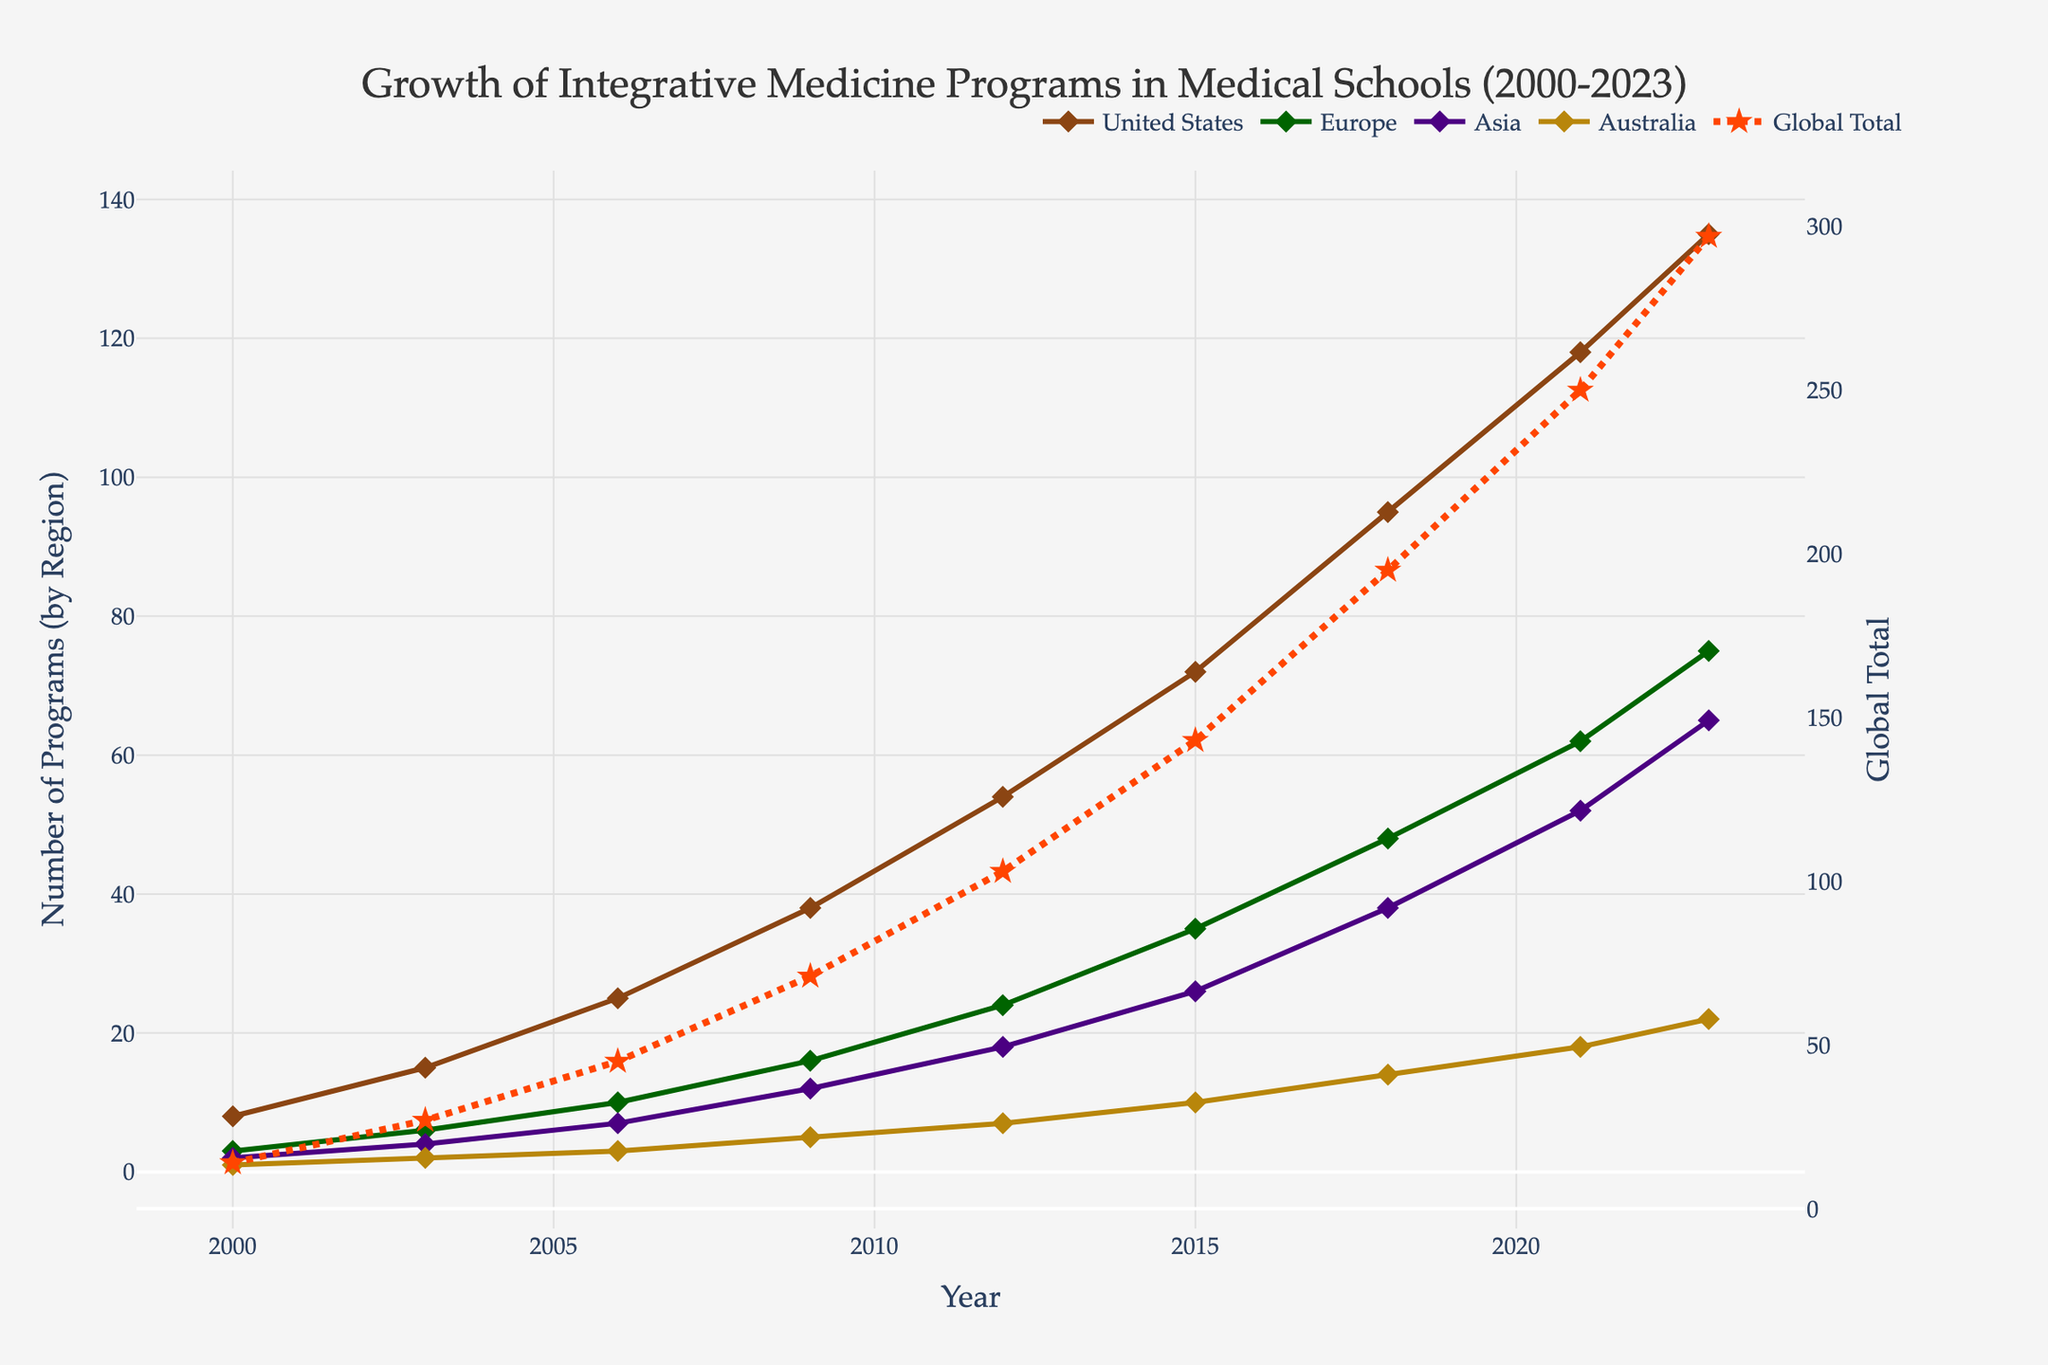What's the total increase in the number of integrative medicine programs globally from 2000 to 2023? To find the total increase, subtract the number of programs in 2000 from the number in 2023. The global total in 2000 is 14 and in 2023 is 297. The increase is 297 - 14 = 283.
Answer: 283 Which region saw the highest increase in the number of programs from 2000 to 2023? Compare the increase in each region from 2000 to 2023. For the United States, the increase is 135 - 8 = 127. For Europe, it's 75 - 3 = 72. For Asia, it's 65 - 2 = 63. For Australia, it's 22 - 1 = 21. The United States has the highest increase.
Answer: United States In 2018, which regions have a similar number of integrative medicine programs? Look at the values for each region in 2018. The United States has 95, Europe has 48, Asia has 38, and Australia has 14. Europe and Asia have relatively closer values compared to the others.
Answer: Europe and Asia What is the average yearly increase in the number of integrative medicine programs in Asia from 2000 to 2023? The increase in Asia is from 2 in 2000 to 65 in 2023, a difference of 63. There are 2023 - 2000 = 23 years. The average yearly increase is 63 / 23 ≈ 2.74.
Answer: 2.74 In which year did the global total of integrative medicine programs surpass 100? Look at the global total across the years. The global total surpasses 100 in 2012 (103).
Answer: 2012 Comparing 2003 and 2009, which region had the greater increase, the United States or Europe? For the United States, the increase from 2003 (15) to 2009 (38) is 38 - 15 = 23. For Europe, it's 16 - 6 = 10. The United States had the greater increase.
Answer: United States What visual elements distinguish the global total line from the region-specific lines? The global total line is represented with a different color (red), a different style (dashed line), and markers are stars instead of diamonds.
Answer: different color, dashed line, star markers What is the overall trend of integrative medicine programs in Australia from 2000 to 2023? Look at the number of programs in Australia over the years: 1 in 2000, 2 in 2003, 3 in 2006, 5 in 2009, 7 in 2012, 10 in 2015, 14 in 2018, 18 in 2021, and 22 in 2023. The trend shows a consistent increase.
Answer: consistent increase Which region had the smallest increase in programs from 2015 to 2021? For the United States, the increase from 2015 (72) to 2021 (118) is 46. For Europe, 35 to 62 is 27. For Asia, 26 to 52 is 26. For Australia, 10 to 18 is 8. Australia had the smallest increase.
Answer: Australia 